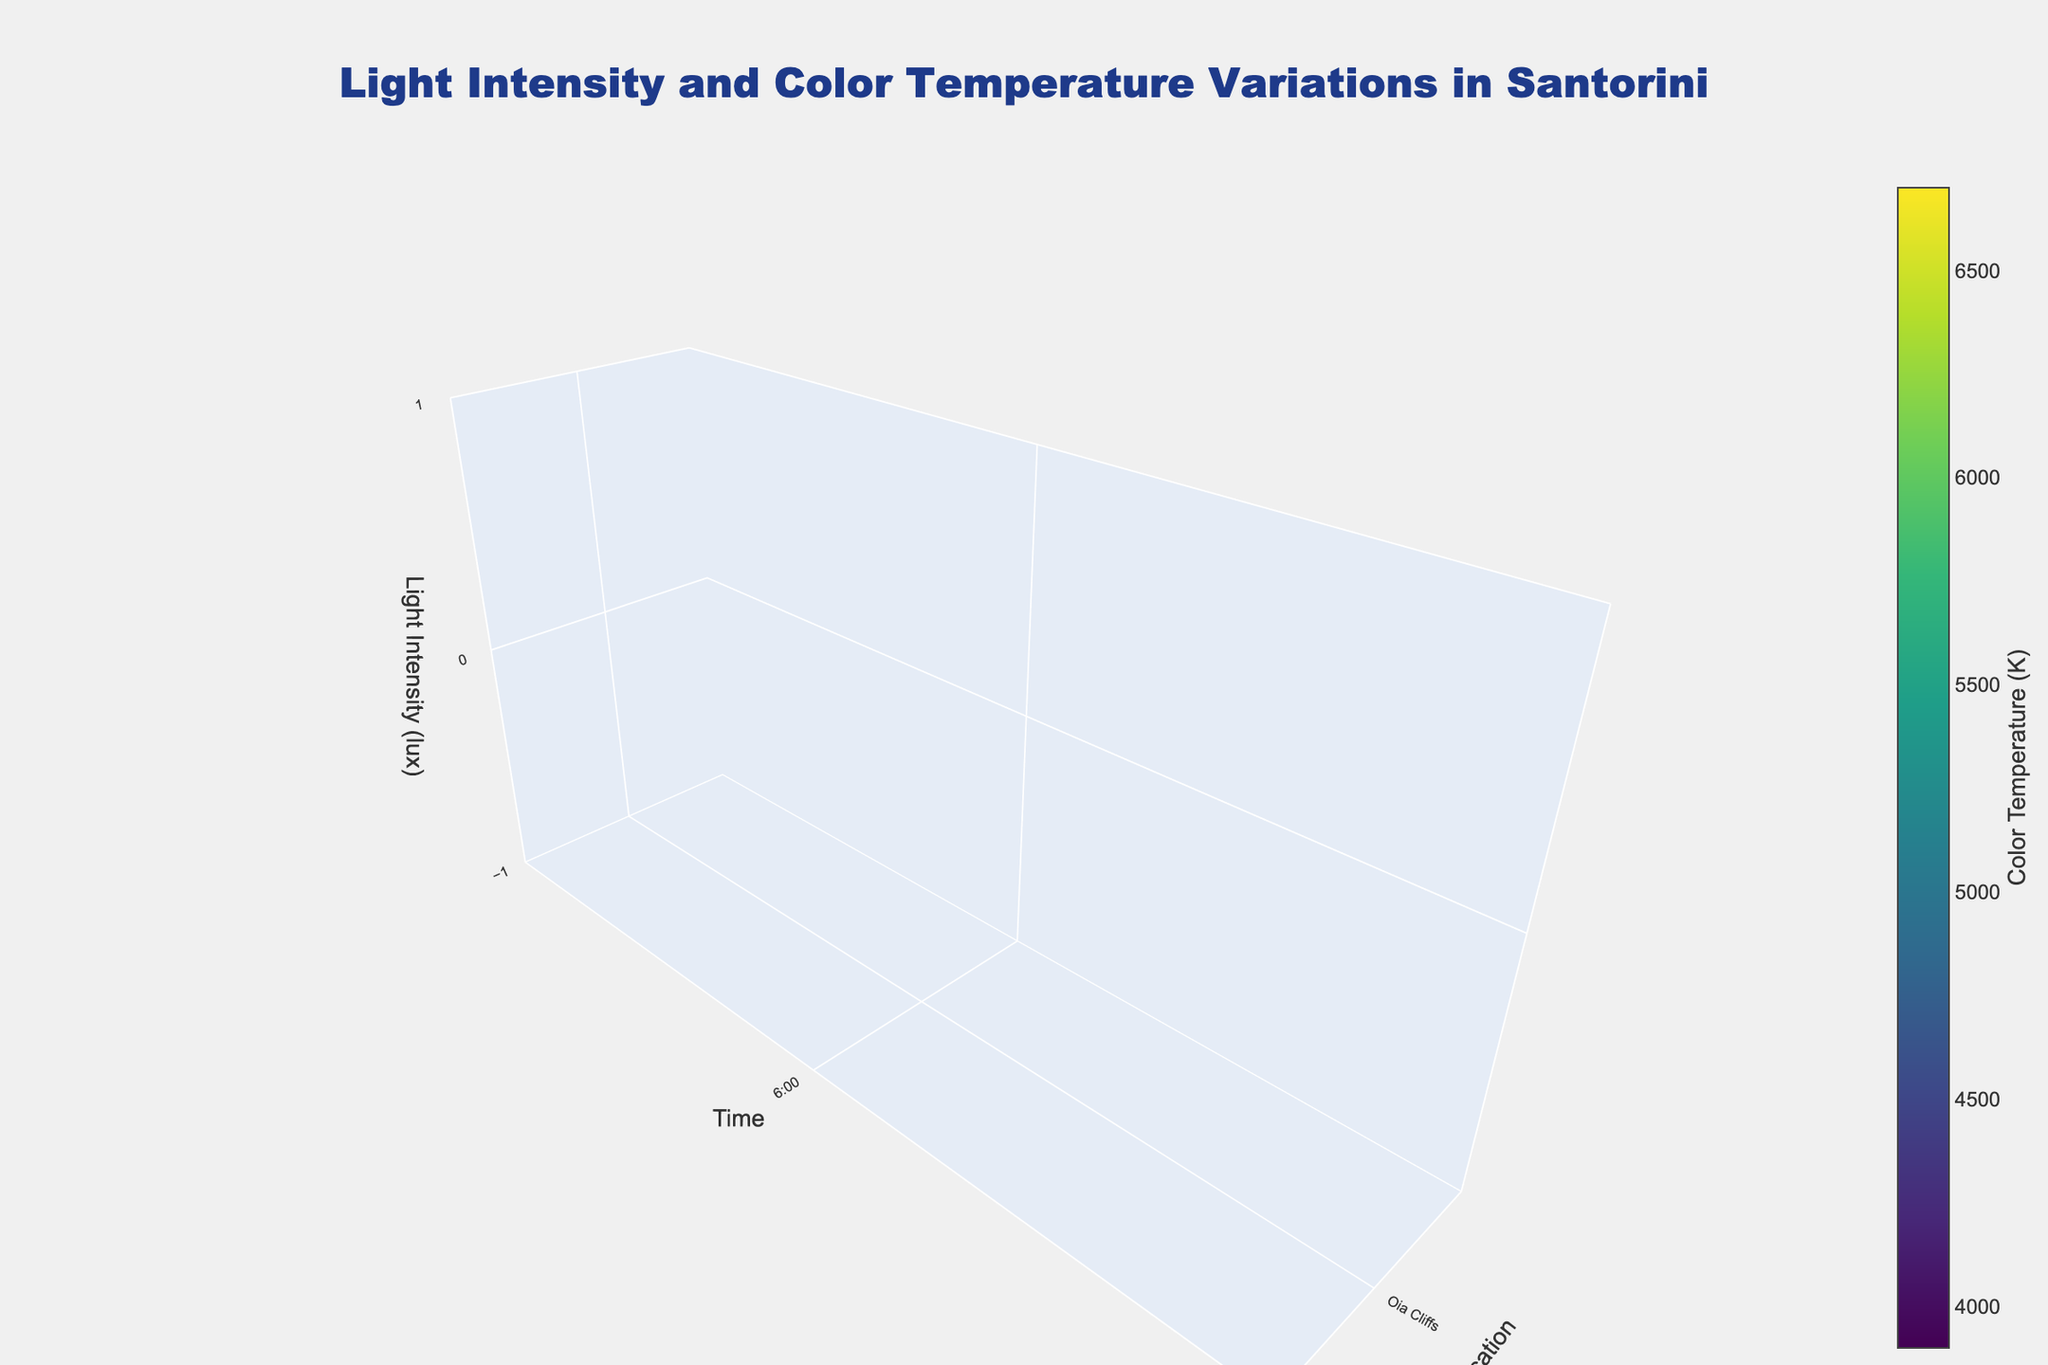What is the title of the figure? Look for the text at the top of the plot that describes the content of the visualization.
Answer: Light Intensity and Color Temperature Variations in Santorini Which location has the highest light intensity at 12:00? Locate the 12:00 time point on the y-axis, and compare the z-values (light intensity) for each location at that time.
Answer: Red Beach How does the color temperature change throughout the day in Oia Cliffs? Examine the color scale and the color changes along the y-axis (time) for Oia Cliffs.
Answer: It decreases consistently Which location has the lowest color temperature at 20:00? Find the 20:00 time point on the y-axis, then compare the color values for each location to identify the darkest shade of color.
Answer: Imerovigli Compare the light intensity at 10:00 between Oia Cliffs and Imerovigli. Which is higher? Compare the z-values (light intensity) at 10:00 between these two locations.
Answer: Oia Cliffs What is the trend of light intensity in Red Beach from 6:00 to 20:00? Look at the z-axis (light intensity) changes for Red Beach along the y-axis (time) from 6:00 to 20:00.
Answer: Peaks at 12:00 and then decreases Which time of day has the widest range of light intensity among the three locations? Observe all locations' z-values at various times and compare the ranges by looking at the highest and lowest light intensity points for each time.
Answer: 12:00 During which time slots do all three locations have approximately the same color temperature? Compare the colors at different times across all locations to find times when the shades are nearly identical.
Answer: 10:00 How does the light intensity at Imerovigli at 16:00 compare to Oia Cliffs at the same time? Compare the z-values (light intensity) between Imerovigli and Oia Cliffs at 16:00.
Answer: Lower Which location experiences the largest decrease in light intensity from 14:00 to 16:00? Compare the z-values from 14:00 to 16:00 for each location, and determine which has the largest difference.
Answer: Oia Cliffs 